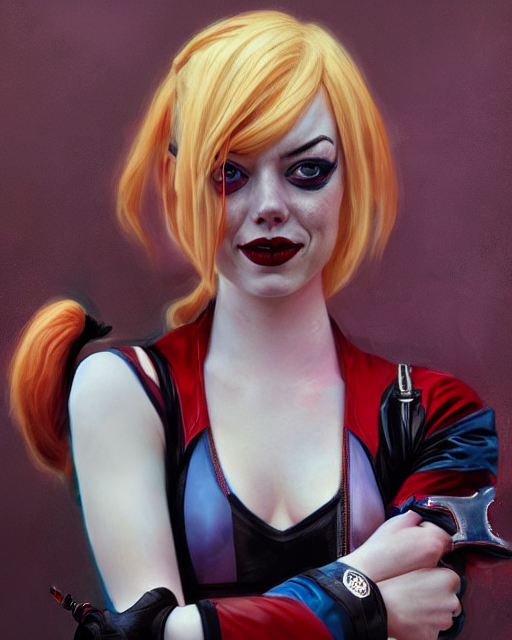How is the lighting in the image?
A. Strong
B. Slightly weak
C. Bright The lighting in the image provides a balanced illumination that accentuates the subject's features without creating harsh shadows or overly bright spots. It appears to be well-managed, skirting between strong and slightly weak, which brings out the rich tones and depth of the image. This suggests a carefully controlled environment, possibly indicative of indoor lighting with softboxes or diffusers. The overall effect is neither too strong to wash out details nor too weak to leave the subject underexposed; instead, it strikes a pleasant middle ground, making it slightly weak (Option B) but still well within the range of being bright and clear. 